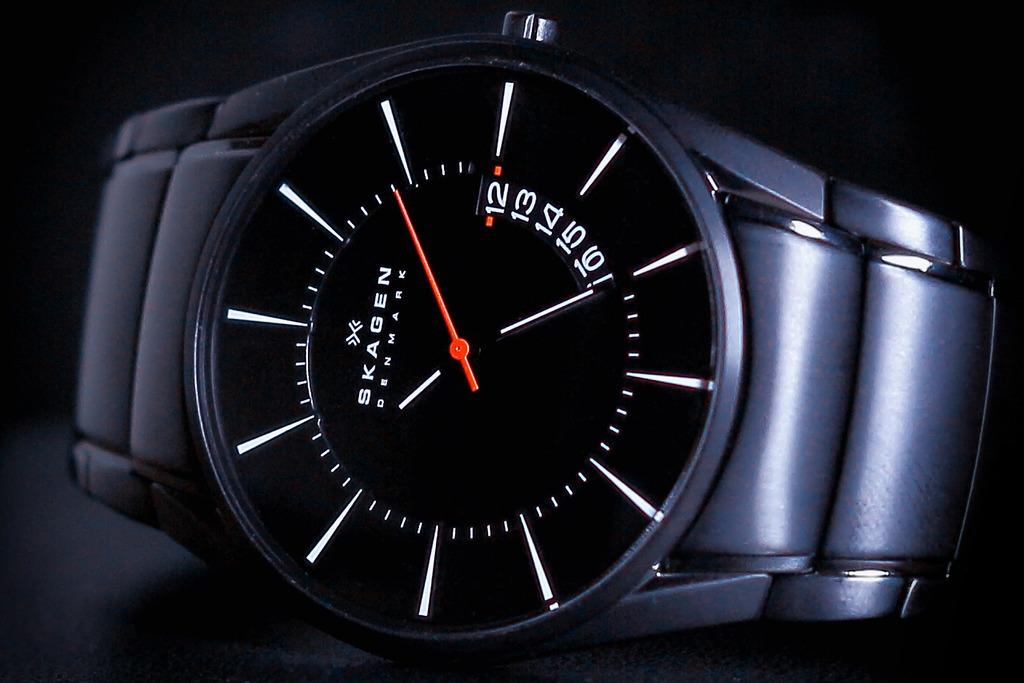<image>
Create a compact narrative representing the image presented. A Skagen watch has a red and white hand but no numbers. 